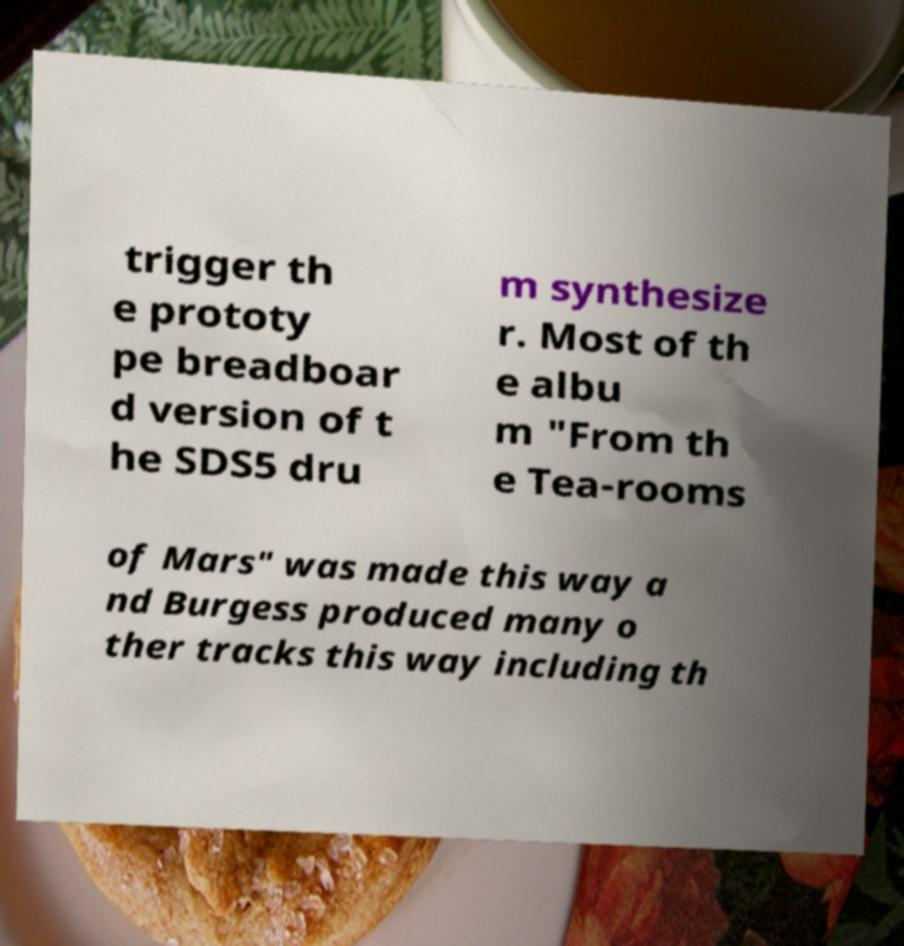Could you assist in decoding the text presented in this image and type it out clearly? trigger th e prototy pe breadboar d version of t he SDS5 dru m synthesize r. Most of th e albu m "From th e Tea-rooms of Mars" was made this way a nd Burgess produced many o ther tracks this way including th 